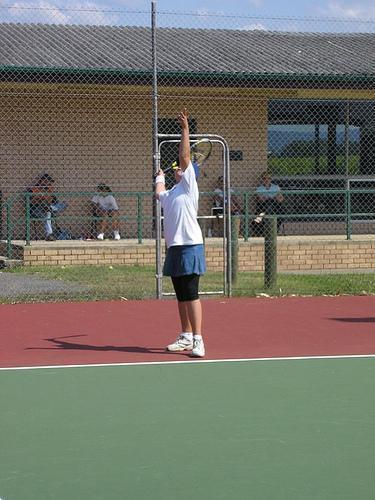How many bikes in this shot?
Give a very brief answer. 0. 